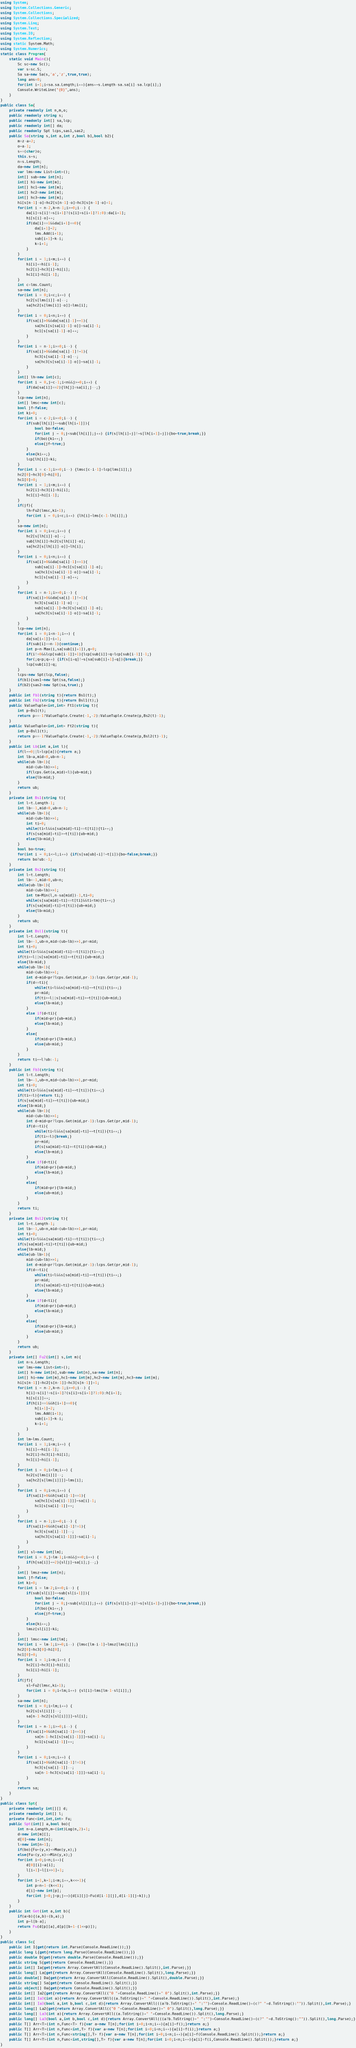Convert code to text. <code><loc_0><loc_0><loc_500><loc_500><_C#_>using System;
using System.Collections.Generic;
using System.Collections;
using System.Collections.Specialized;
using System.Linq;
using System.Text;
using System.IO;
using System.Reflection;
using static System.Math;
using System.Numerics;
static class Program{
	static void Main(){
		Sc sc=new Sc();
		var s=sc.S;
		Sa sa=new Sa(s,'a','z',true,true);
		long ans=0;
		for(int i=1;i<sa.sa.Length;i++){ans+=s.Length-sa.sa[i]-sa.lcp[i];}
		Console.WriteLine("{0}",ans);
	}
}
public class Sa{
	private readonly int n,m,o;
	public readonly string s;
	public readonly int[] sa,lcp;
	public readonly int[] da;
	public readonly Spt lcps,sas1,sas2;
	public Sa(string s,int a,int z,bool b1,bool b2){
		m=z-a+2;
		o=a-1;
		s+=(char)o;
		this.s=s;
		n=s.Length;
		da=new int[n];
		var lms=new List<int>();
		int[] sub=new int[n];
		int[] hi=new int[m];
		int[] hc1=new int[m];
		int[] hc2=new int[m];
		int[] hc3=new int[m];
		hi[s[n-1]-o]=hc2[s[n-1]-o]=hc3[s[n-1]-o]=1;
		for(int i = n-2,k=n-1;i>=0;i--) {
			da[i]=s[i]!=s[i+1]?(s[i]>s[i+1]?1:0):da[i+1];
			hi[s[i]-o]++;
			if(da[i]==1&&da[i+1]==0){
				da[i+1]=2;
				lms.Add(i+1);
				sub[i+1]=k-i;
				k=i+1;
			}
		}
		for(int i = 1;i<m;i++) {
			hi[i]+=hi[i-1];
			hc2[i]=hc3[i]=hi[i];
			hc1[i]=hi[i-1];
		}
		int c=lms.Count;
		sa=new int[n];
		for(int i = 0;i<c;i++) {
			hc2[s[lms[i]]-o]--;
			sa[hc2[s[lms[i]]-o]]=lms[i];
		}
		for(int i = 0;i<n;i++) {
			if(sa[i]>0&&da[sa[i]-1]==1){
				sa[hc1[s[sa[i]-1]-o]]=sa[i]-1;
				hc1[s[sa[i]-1]-o]++;
			}
		}
		for(int i = n-1;i>=0;i--) {
			if(sa[i]>0&&da[sa[i]-1]!=1){
				hc3[s[sa[i]-1]-o]--;
				sa[hc3[s[sa[i]-1]-o]]=sa[i]-1;
			}
		}
		int[] lh=new int[c];
		for(int i = 0,j=c-1;i<n&&j>=0;i++) {
			if(da[sa[i]]==2){lh[j]=sa[i];j--;}
		}
		lcp=new int[n];
		int[] lmsc=new int[c];
		bool jf=false;
		int ki=0;
		for(int i = c-2;i>=0;i--) {
			if(sub[lh[i]]==sub[lh[i+1]]){
				bool bo=false;
				for(int j = 0;j<sub[lh[i]];j++) {if(s[lh[i]+j]!=s[lh[i+1]+j]){bo=true;break;}}
				if(bo){ki++;}
				else{jf=true;}
			}
			else{ki++;}
			lcp[lh[i]]=ki;
		}
		for(int i = c-1;i>=0;i--) {lmsc[c-i-1]=lcp[lms[i]];}
		hc2[0]=hc3[0]=hi[0];
		hc1[0]=0;
		for(int i = 1;i<m;i++) {
			hc2[i]=hc3[i]=hi[i];
			hc1[i]=hi[i-1];
		}
		if(jf){
			lh=Fu2(lmsc,ki+1);
			for(int i = 0;i<c;i++) {lh[i]=lms[c-1-lh[i]];}
		}
		sa=new int[n];
		for(int i = 0;i<c;i++) {
			hc2[s[lh[i]]-o]--;
			sub[lh[i]]=hc2[s[lh[i]]-o];
			sa[hc2[s[lh[i]]-o]]=lh[i];
		}
		for(int i = 0;i<n;i++) {
			if(sa[i]>0&&da[sa[i]-1]==1){
				sub[sa[i]-1]=hc1[s[sa[i]-1]-o];
				sa[hc1[s[sa[i]-1]-o]]=sa[i]-1;
				hc1[s[sa[i]-1]-o]++;
			}
		}
		for(int i = n-1;i>=0;i--) {
			if(sa[i]>0&&da[sa[i]-1]!=1){
				hc3[s[sa[i]-1]-o]--;
				sub[sa[i]-1]=hc3[s[sa[i]-1]-o];
				sa[hc3[s[sa[i]-1]-o]]=sa[i]-1;
			}
		}
		lcp=new int[n];
		for(int i = 0;i<n-1;i++) {
			da[sa[i+1]]=i+1;
			if(sub[i]==n-1){continue;}
			int p=n-Max(i,sa[sub[i]+1]),q=0;
			if(i!=0&&lcp[sub[i-1]]>1){lcp[sub[i]]=q=lcp[sub[i-1]]-1;}
			for(;q<p;q++) {if(s[i+q]!=s[sa[sub[i]+1]+q]){break;}}
			lcp[sub[i]]=q;
		}
		lcps=new Spt(lcp,false);
		if(b1){sas1=new Spt(sa,false);}
		if(b2){sas2=new Spt(sa,true);}
	}
	public int Fb1(string t){return Bs1(t);}
	public int Fb2(string t){return Bsl1(t);}
	public ValueTuple<int,int> Ft1(string t){
		int p=Bs1(t);
		return p==-1?ValueTuple.Create(-1,-2):ValueTuple.Create(p,Bs2(t)-1);
	}
	public ValueTuple<int,int> Ft2(string t){
		int p=Bsl1(t);
		return p==-1?ValueTuple.Create(-1,-2):ValueTuple.Create(p,Bsl2(t)-1);
	}
	public int Lb(int a,int l){
		if(l==0||l>lcp[a]){return a;}
		int lb=a,mid=0,ub=n-1;
		while(ub-lb>1){
			mid=(ub+lb)>>1;
			if(lcps.Get(a,mid)<l){ub=mid;}
			else{lb=mid;}
		}
		return ub;
	}
	private int Bs1(string t){
		int l=t.Length-1;
		int lb=-1,mid=0,ub=n-1;
		while(ub-lb>1){
			mid=(ub+lb)>>1;
			int ti=0;
			while(ti<l&&s[sa[mid]+ti]==t[ti]){ti++;}
			if(s[sa[mid]+ti]>=t[ti]){ub=mid;}
			else{lb=mid;}
		}
		bool bo=true;
		for(int i = 0;i<=l;i++) {if(s[sa[ub]+i]!=t[i]){bo=false;break;}}
		return bo?ub:-1;
	}
	private int Bs2(string t){
		int l=t.Length;
		int lb=-1,mid=0,ub=n;
		while(ub-lb>1){
			mid=(ub+lb)>>1;
			int tm=Min(l,n-sa[mid])-1,ti=0;
			while(s[sa[mid]+ti]==t[ti]&&ti<tm){ti++;}
			if(s[sa[mid]+ti]>t[ti]){ub=mid;}
			else{lb=mid;}
		}
		return ub;
	}
	private int Bsl1(string t){
		int l=t.Length;
		int lb=-1,ub=n,mid=(ub+lb)>>1,pr=mid;
		int ti=0;
		while(ti<l&&s[sa[mid]+ti]==t[ti]){ti++;}
		if(ti>=l||s[sa[mid]+ti]>=t[ti]){ub=mid;}
		else{lb=mid;}
		while(ub-lb>1){
			mid=(ub+lb)>>1;
			int d=mid<pr?lcps.Get(mid,pr-1):lcps.Get(pr,mid-1);
			if(d==ti){
				while(ti<l&&s[sa[mid]+ti]==t[ti]){ti++;}
				pr=mid;
				if(ti>=l||s[sa[mid]+ti]>=t[ti]){ub=mid;}
				else{lb=mid;}
			}
			else if(d<ti){
				if(mid>pr){ub=mid;}
				else{lb=mid;}
			}
			else{
				if(mid>pr){lb=mid;}
				else{ub=mid;}
			}
		}
		return ti==l?ub:-1;
	}
	public int Fb3(string t){
		int l=t.Length;
		int lb=-1,ub=n,mid=(ub+lb)>>1,pr=mid;
		int ti=0;
		while(ti<l&&s[sa[mid]+ti]==t[ti]){ti++;}
		if(ti>=l){return ti;}
		if(s[sa[mid]+ti]>=t[ti]){ub=mid;}
		else{lb=mid;}
		while(ub-lb>1){
			mid=(ub+lb)>>1;
			int d=mid<pr?lcps.Get(mid,pr-1):lcps.Get(pr,mid-1);
			if(d==ti){
				while(ti<l&&s[sa[mid]+ti]==t[ti]){ti++;}
				if(ti>=l){break;}
				pr=mid;
				if(s[sa[mid]+ti]>=t[ti]){ub=mid;}
				else{lb=mid;}
			}
			else if(d<ti){
				if(mid>pr){ub=mid;}
				else{lb=mid;}
			}
			else{
				if(mid>pr){lb=mid;}
				else{ub=mid;}
			}
		}
		return ti;
	}
	private int Bsl2(string t){
		int l=t.Length-1;
		int lb=-1,ub=n,mid=(ub+lb)>>1,pr=mid;
		int ti=0;
		while(ti<l&&s[sa[mid]+ti]==t[ti]){ti++;}
		if(s[sa[mid]+ti]>t[ti]){ub=mid;}
		else{lb=mid;}
		while(ub-lb>1){
			mid=(ub+lb)>>1;
			int d=mid<pr?lcps.Get(mid,pr-1):lcps.Get(pr,mid-1);
			if(d==ti){
				while(ti<l&&s[sa[mid]+ti]==t[ti]){ti++;}
				pr=mid;
				if(s[sa[mid]+ti]>t[ti]){ub=mid;}
				else{lb=mid;}
			}
			else if(d<ti){
				if(mid>pr){ub=mid;}
				else{lb=mid;}
			}
			else{
				if(mid>pr){lb=mid;}
				else{ub=mid;}
			}
		}
		return ub;
	}
	private int[] Fu2(int[] s,int m){
		int n=s.Length;
		var lms=new List<int>();
		int[] h=new int[n],sub=new int[n],sa=new int[n];
		int[] hi=new int[m],hc1=new int[m],hc2=new int[m],hc3=new int[m];
		hi[s[n-1]]=hc2[s[n-1]]=hc3[s[n-1]]=1;
		for(int i = n-2,k=n-1;i>=0;i--) {
			h[i]=s[i]!=s[i+1]?(s[i]>s[i+1]?1:0):h[i+1];
			hi[s[i]]++;
			if(h[i]==1&&h[i+1]==0){
				h[i+1]=2;
				lms.Add(i+1);
				sub[i+1]=k-i;
				k=i+1;
			}
		}
		int lm=lms.Count;
		for(int i = 1;i<m;i++) {
			hi[i]+=hi[i-1];
			hc2[i]=hc3[i]=hi[i];
			hc1[i]=hi[i-1];
		}
		for(int i = 0;i<lm;i++) {
			hc2[s[lms[i]]]--;
			sa[hc2[s[lms[i]]]]=lms[i];
		}
		for(int i = 0;i<n;i++) {
			if(sa[i]>0&&h[sa[i]-1]==1){
				sa[hc1[s[sa[i]-1]]]=sa[i]-1;
				hc1[s[sa[i]-1]]++;
			}
		}
		for(int i = n-1;i>=0;i--) {
			if(sa[i]>0&&h[sa[i]-1]!=1){
				hc3[s[sa[i]-1]]--;
				sa[hc3[s[sa[i]-1]]]=sa[i]-1;
			}
		}
		int[] sl=new int[lm];
		for(int i = 0,j=lm-1;i<n&&j>=0;i++) {
			if(h[sa[i]]==2){sl[j]=sa[i];j--;}
		}
		int[] lmsz=new int[n];
		bool jf=false;
		int ki=0;
		for(int i = lm-2;i>=0;i--) {
			if(sub[sl[i]]==sub[sl[i+1]]){
				bool bo=false;
				for(int j = 0;j<sub[sl[i]];j++) {if(s[sl[i]+j]!=s[sl[i+1]+j]){bo=true;break;}}
				if(bo){ki++;}
				else{jf=true;}
			}
			else{ki++;}
			lmsz[sl[i]]=ki;
		}
		int[] lmsc=new int[lm];
		for(int i = lm-1;i>=0;i--) {lmsc[lm-i-1]=lmsz[lms[i]];}
		hc2[0]=hc3[0]=hi[0];
		hc1[0]=0;
		for(int i = 1;i<m;i++) {
			hc2[i]=hc3[i]=hi[i];
			hc1[i]=hi[i-1];
		}
		if(jf){
			sl=Fu2(lmsc,ki+1);
			for(int i = 0;i<lm;i++) {sl[i]=lms[lm-1-sl[i]];}
		}
		sa=new int[n];
		for(int i = 0;i<lm;i++) {
			hc2[s[sl[i]]]--;
			sa[n-1-hc2[s[sl[i]]]]=sl[i];
		}
		for(int i = n-1;i>=0;i--) {
			if(sa[i]>0&&h[sa[i]-1]==1){
				sa[n-1-hc1[s[sa[i]-1]]]=sa[i]-1;
				hc1[s[sa[i]-1]]++;
			}
		}
		for(int i = 0;i<n;i++) {
			if(sa[i]>0&&h[sa[i]-1]!=1){
				hc3[s[sa[i]-1]]--;
				sa[n-1-hc3[s[sa[i]-1]]]=sa[i]-1;
			}
		}
		return sa;
	}
}
public class Spt{
	private readonly int[][] d;
	private readonly int[] l;
	private Func<int,int,int> Fu;
	public Spt(int[] a,bool bo){
		int n=a.Length,m=(int)Log(n,2)+1;
		d=new int[m][];
		d[0]=new int[n];
		l=new int[n+1];
		if(bo){Fu=(y,x)=>Max(y,x);}
		else{Fu=(y,x)=>Min(y,x);}
		for(int i=0;i<n;i++){
			d[0][i]=a[i];
			l[i+1]=l[i>>1]+1;
		}
		for(int i=1,k=1;i<m;i++,k<<=1){
			int p=n+1-(k<<1);
			d[i]=new int[p];
			for(int j=0;j<p;j++){d[i][j]=Fu(d[i-1][j],d[i-1][j+k]);}
		}
	}
	public int Get(int a,int b){
		if(a>b){(a,b)=(b,a);}
		int p=l[b-a];
		return Fu(d[p][a],d[p][b+1-(1<<p)]);
	}
}
public class Sc{
	public int I{get{return int.Parse(Console.ReadLine());}}
	public long L{get{return long.Parse(Console.ReadLine());}}
	public double D{get{return double.Parse(Console.ReadLine());}}
	public string S{get{return Console.ReadLine();}}
	public int[] Ia{get{return Array.ConvertAll(Console.ReadLine().Split(),int.Parse);}}
	public long[] La{get{return Array.ConvertAll(Console.ReadLine().Split(),long.Parse);}}
	public double[] Da{get{return Array.ConvertAll(Console.ReadLine().Split(),double.Parse);}}
	public string[] Sa{get{return Console.ReadLine().Split();}}
	public object[] Oa{get{return Console.ReadLine().Split();}}
	public int[] Ia2{get{return Array.ConvertAll(("0 "+Console.ReadLine()+" 0").Split(),int.Parse);}}
	public int[] Ia3(int a){return Array.ConvertAll((a.ToString()+" "+Console.ReadLine()).Split(),int.Parse);}
	public int[] Ia3(bool a,int b,bool c,int d){return Array.ConvertAll(((a?b.ToString()+" ":"")+Console.ReadLine()+(c?" "+d.ToString():"")).Split(),int.Parse);}
	public long[] La2{get{return Array.ConvertAll(("0 "+Console.ReadLine()+" 0").Split(),long.Parse);}}
	public long[] La3(int a){return Array.ConvertAll((a.ToString()+" "+Console.ReadLine()).Split(),long.Parse);}
	public long[] La3(bool a,int b,bool c,int d){return Array.ConvertAll(((a?b.ToString()+" ":"")+Console.ReadLine()+(c?" "+d.ToString():"")).Split(),long.Parse);}
	public T[] Arr<T>(int n,Func<T> f){var a=new T[n];for(int i=0;i<n;i++){a[i]=f();}return a;}
	public T[] Arr<T>(int n,Func<int,T> f){var a=new T[n];for(int i=0;i<n;i++){a[i]=f(i);}return a;}
	public T[] Arr<T>(int n,Func<string[],T> f){var a=new T[n];for(int i=0;i<n;i++){a[i]=f(Console.ReadLine().Split());}return a;}
	public T[] Arr<T>(int n,Func<int,string[],T> f){var a=new T[n];for(int i=0;i<n;i++){a[i]=f(i,Console.ReadLine().Split());}return a;}
}</code> 